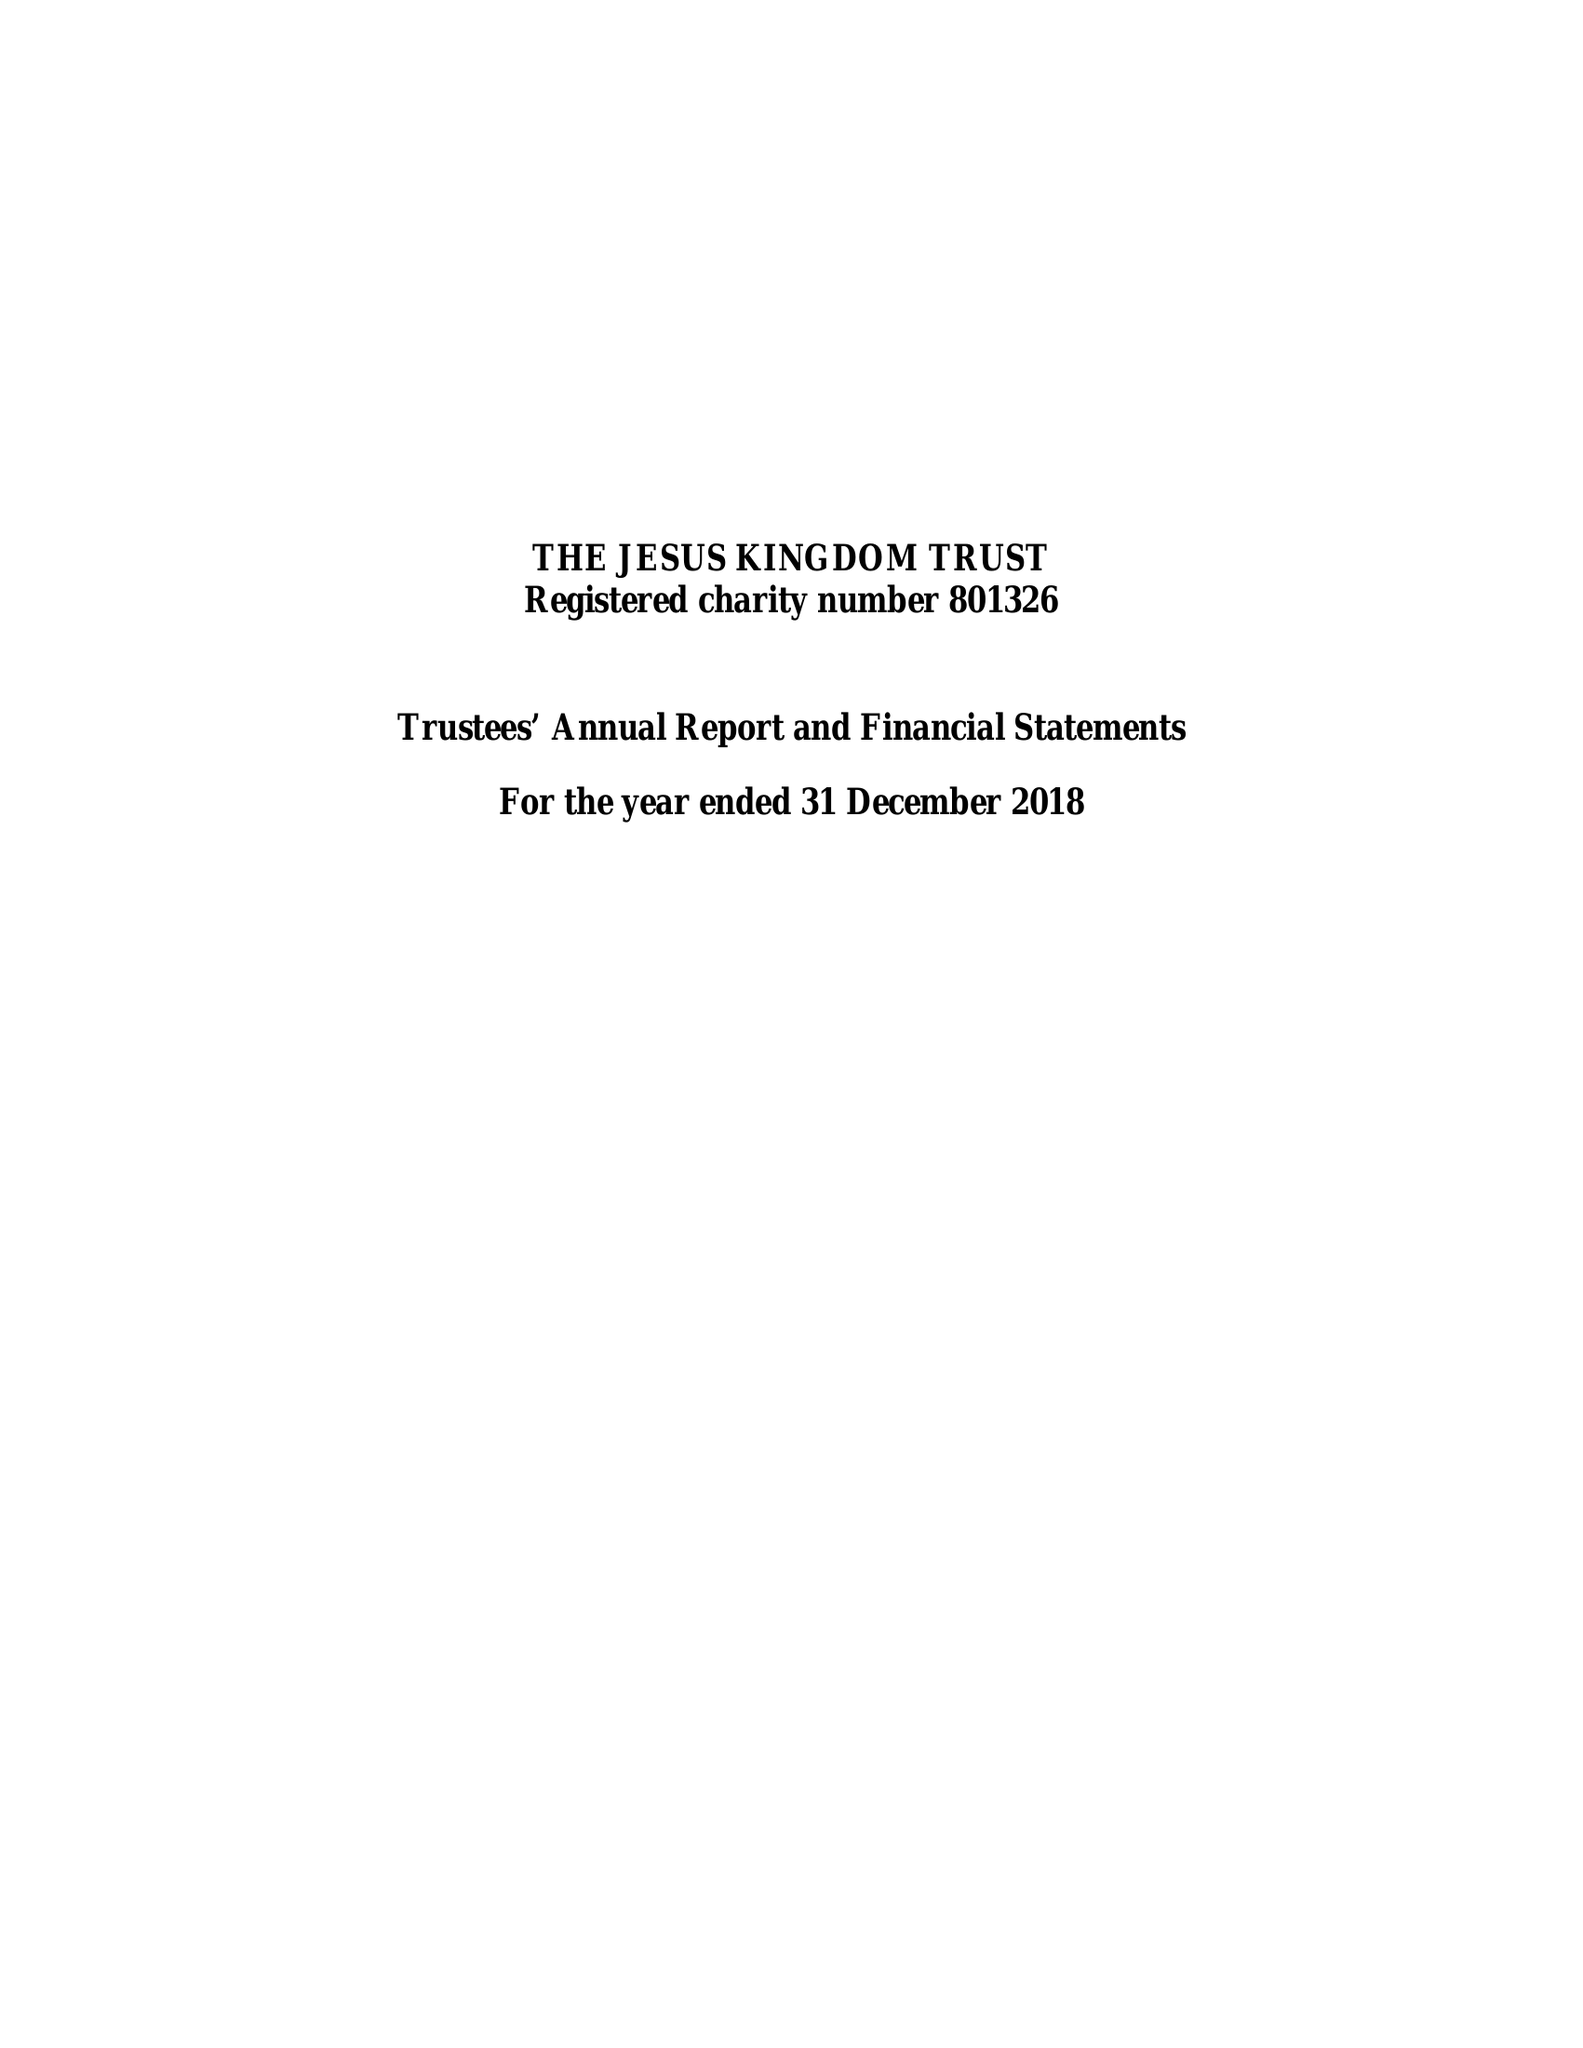What is the value for the address__post_town?
Answer the question using a single word or phrase. LONDON 